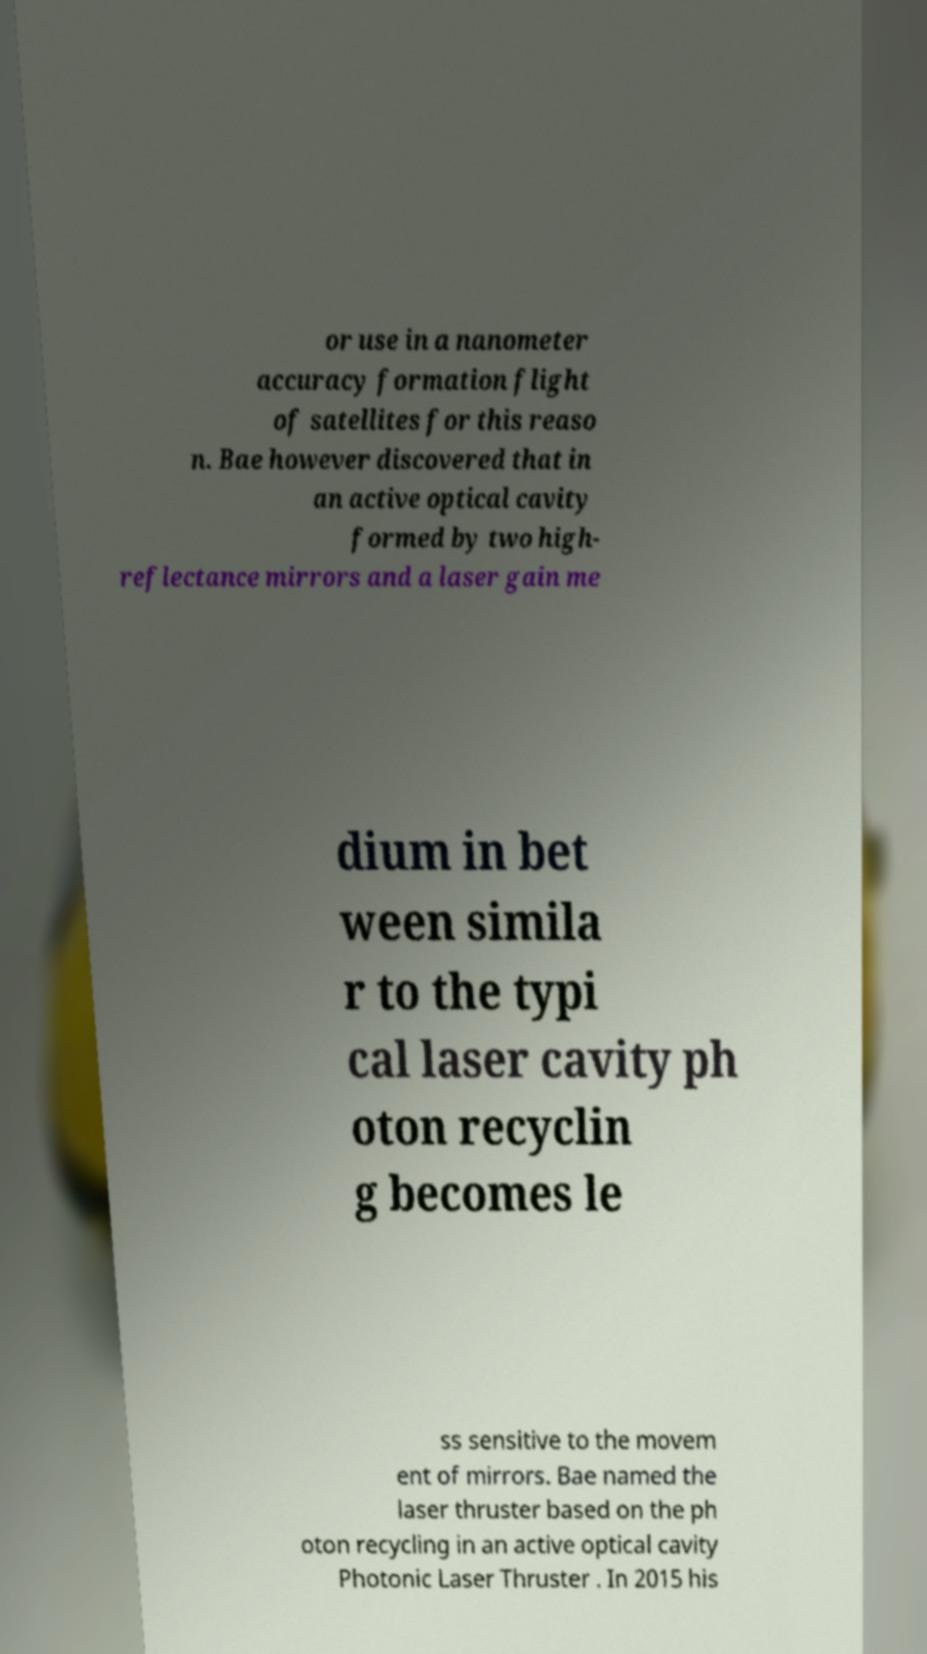Please read and relay the text visible in this image. What does it say? or use in a nanometer accuracy formation flight of satellites for this reaso n. Bae however discovered that in an active optical cavity formed by two high- reflectance mirrors and a laser gain me dium in bet ween simila r to the typi cal laser cavity ph oton recyclin g becomes le ss sensitive to the movem ent of mirrors. Bae named the laser thruster based on the ph oton recycling in an active optical cavity Photonic Laser Thruster . In 2015 his 